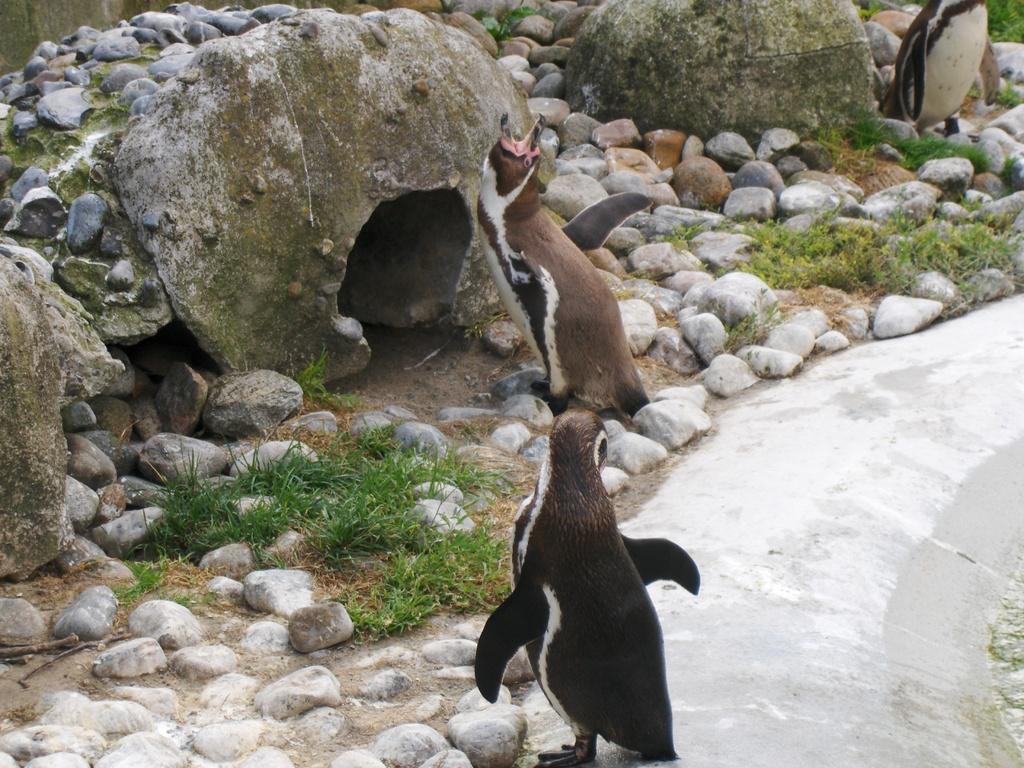Can you describe this image briefly? In the picture we can see some penguins which are on ground, there are some stones, grass. 